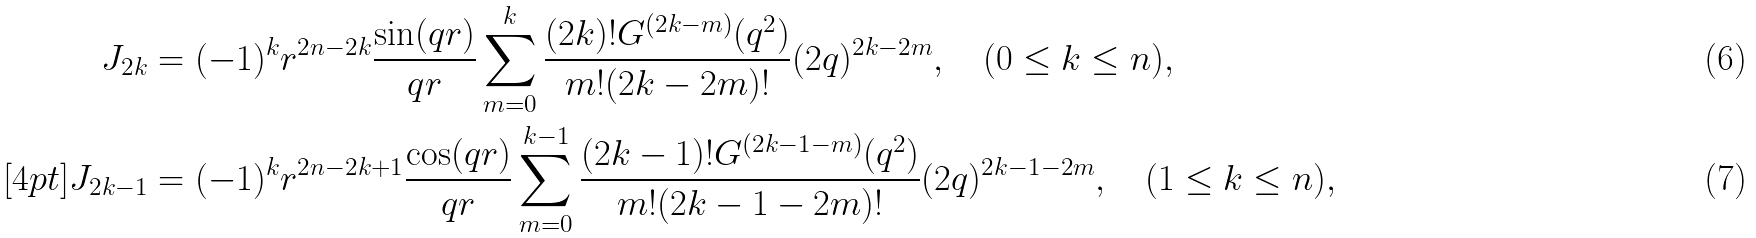<formula> <loc_0><loc_0><loc_500><loc_500>J _ { 2 k } & = ( - 1 ) ^ { k } r ^ { 2 n - 2 k } \frac { \sin ( q r ) } { q r } \sum _ { m = 0 } ^ { k } \frac { ( 2 k ) ! G ^ { ( 2 k - m ) } ( q ^ { 2 } ) } { m ! ( 2 k - 2 m ) ! } ( 2 q ) ^ { 2 k - 2 m } , \quad ( 0 \leq k \leq n ) , \\ [ 4 p t ] J _ { 2 k - 1 } & = ( - 1 ) ^ { k } r ^ { 2 n - 2 k + 1 } \frac { \cos ( q r ) } { q r } \sum _ { m = 0 } ^ { k - 1 } \frac { ( 2 k - 1 ) ! G ^ { ( 2 k - 1 - m ) } ( q ^ { 2 } ) } { m ! ( 2 k - 1 - 2 m ) ! } ( 2 q ) ^ { 2 k - 1 - 2 m } , \quad ( 1 \leq k \leq n ) ,</formula> 